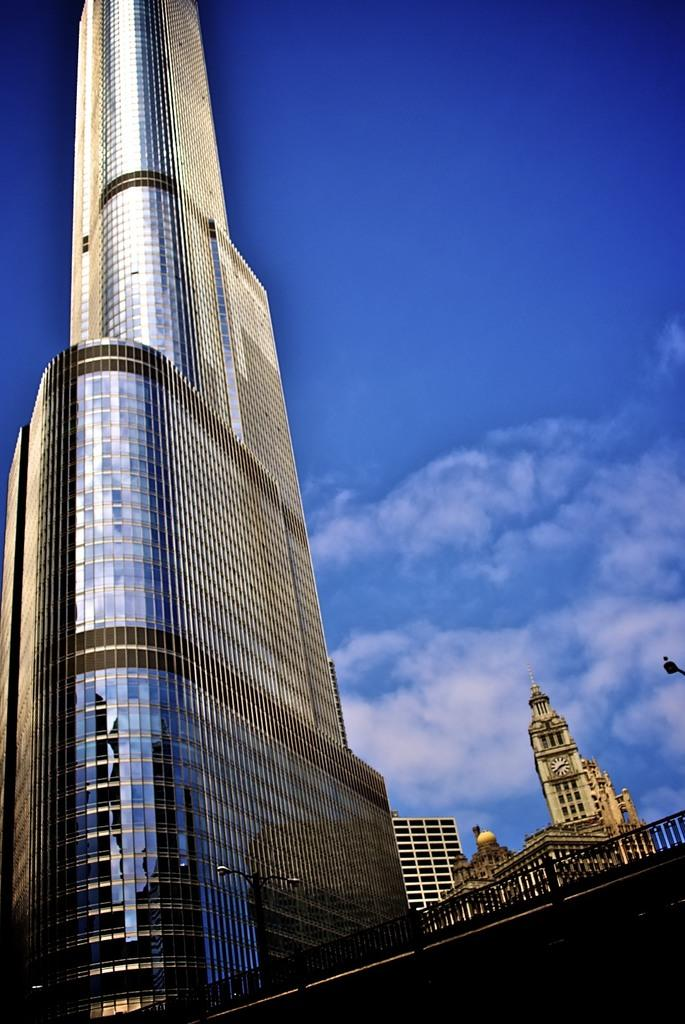What type of structures can be seen in the image? There are buildings in the image. What other objects are present in the image? There are poles and metal rods in the image. What can be seen in the sky in the image? There are clouds visible in the image. What type of advice can be seen written on the buildings in the image? There is no advice written on the buildings in the image; the image only shows buildings, poles, metal rods, and clouds. Are there any dinosaurs visible in the image? There are no dinosaurs present in the image. 